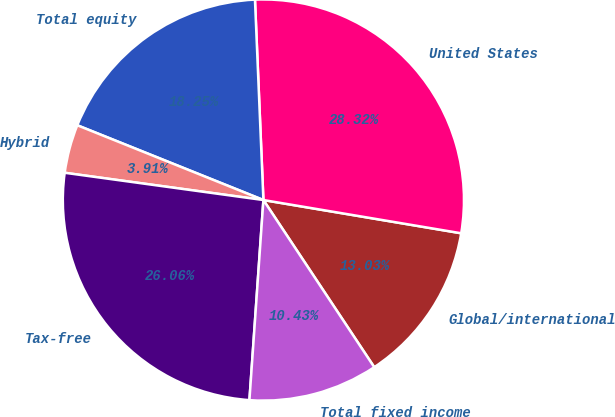Convert chart. <chart><loc_0><loc_0><loc_500><loc_500><pie_chart><fcel>Global/international<fcel>United States<fcel>Total equity<fcel>Hybrid<fcel>Tax-free<fcel>Total fixed income<nl><fcel>13.03%<fcel>28.32%<fcel>18.25%<fcel>3.91%<fcel>26.06%<fcel>10.43%<nl></chart> 